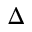Convert formula to latex. <formula><loc_0><loc_0><loc_500><loc_500>\Delta</formula> 